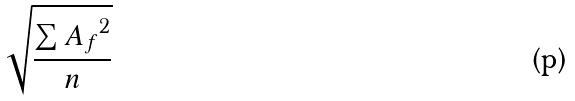<formula> <loc_0><loc_0><loc_500><loc_500>\sqrt { \frac { \sum { A _ { f } } ^ { 2 } } { n } }</formula> 